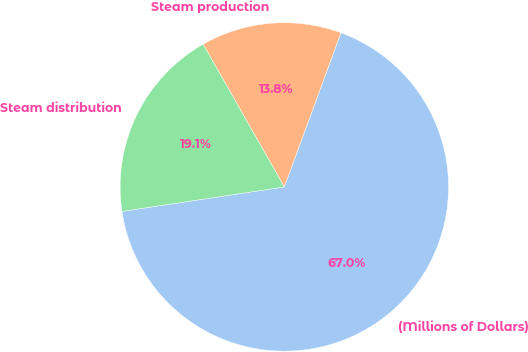Convert chart to OTSL. <chart><loc_0><loc_0><loc_500><loc_500><pie_chart><fcel>(Millions of Dollars)<fcel>Steam production<fcel>Steam distribution<nl><fcel>67.02%<fcel>13.83%<fcel>19.15%<nl></chart> 